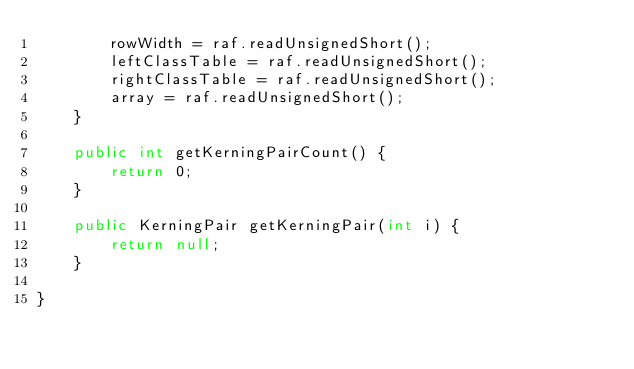Convert code to text. <code><loc_0><loc_0><loc_500><loc_500><_Java_>        rowWidth = raf.readUnsignedShort();
        leftClassTable = raf.readUnsignedShort();
        rightClassTable = raf.readUnsignedShort();
        array = raf.readUnsignedShort();
    }

    public int getKerningPairCount() {
        return 0;
    }

    public KerningPair getKerningPair(int i) {
        return null;
    }

}
</code> 